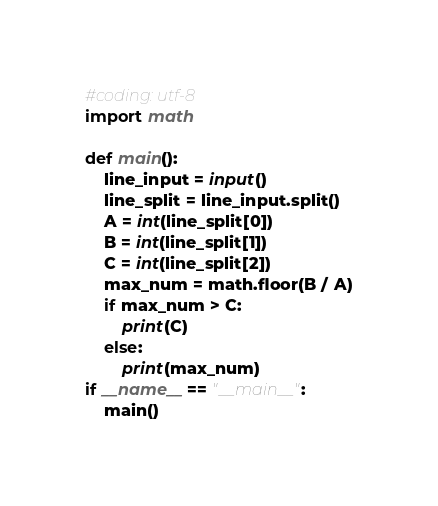<code> <loc_0><loc_0><loc_500><loc_500><_Python_>#coding: utf-8
import math

def main():
    line_input = input()
    line_split = line_input.split()
    A = int(line_split[0])
    B = int(line_split[1])
    C = int(line_split[2])
    max_num = math.floor(B / A)
    if max_num > C:
        print(C)
    else:
        print(max_num)
if __name__ == "__main__":
    main()</code> 